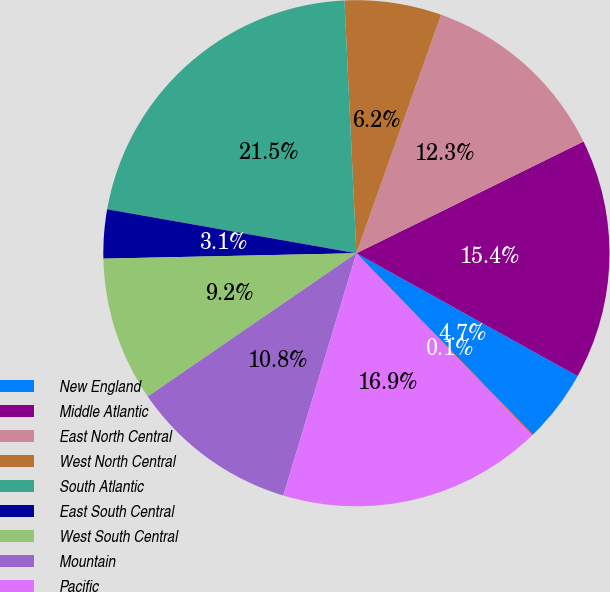Convert chart. <chart><loc_0><loc_0><loc_500><loc_500><pie_chart><fcel>New England<fcel>Middle Atlantic<fcel>East North Central<fcel>West North Central<fcel>South Atlantic<fcel>East South Central<fcel>West South Central<fcel>Mountain<fcel>Pacific<fcel>Valuation allowance<nl><fcel>4.65%<fcel>15.35%<fcel>12.29%<fcel>6.18%<fcel>21.47%<fcel>3.12%<fcel>9.24%<fcel>10.76%<fcel>16.88%<fcel>0.06%<nl></chart> 